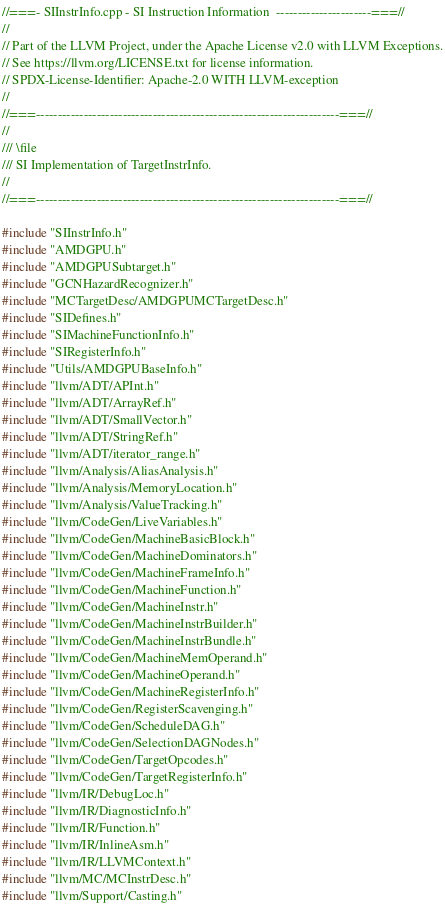<code> <loc_0><loc_0><loc_500><loc_500><_C++_>//===- SIInstrInfo.cpp - SI Instruction Information  ----------------------===//
//
// Part of the LLVM Project, under the Apache License v2.0 with LLVM Exceptions.
// See https://llvm.org/LICENSE.txt for license information.
// SPDX-License-Identifier: Apache-2.0 WITH LLVM-exception
//
//===----------------------------------------------------------------------===//
//
/// \file
/// SI Implementation of TargetInstrInfo.
//
//===----------------------------------------------------------------------===//

#include "SIInstrInfo.h"
#include "AMDGPU.h"
#include "AMDGPUSubtarget.h"
#include "GCNHazardRecognizer.h"
#include "MCTargetDesc/AMDGPUMCTargetDesc.h"
#include "SIDefines.h"
#include "SIMachineFunctionInfo.h"
#include "SIRegisterInfo.h"
#include "Utils/AMDGPUBaseInfo.h"
#include "llvm/ADT/APInt.h"
#include "llvm/ADT/ArrayRef.h"
#include "llvm/ADT/SmallVector.h"
#include "llvm/ADT/StringRef.h"
#include "llvm/ADT/iterator_range.h"
#include "llvm/Analysis/AliasAnalysis.h"
#include "llvm/Analysis/MemoryLocation.h"
#include "llvm/Analysis/ValueTracking.h"
#include "llvm/CodeGen/LiveVariables.h"
#include "llvm/CodeGen/MachineBasicBlock.h"
#include "llvm/CodeGen/MachineDominators.h"
#include "llvm/CodeGen/MachineFrameInfo.h"
#include "llvm/CodeGen/MachineFunction.h"
#include "llvm/CodeGen/MachineInstr.h"
#include "llvm/CodeGen/MachineInstrBuilder.h"
#include "llvm/CodeGen/MachineInstrBundle.h"
#include "llvm/CodeGen/MachineMemOperand.h"
#include "llvm/CodeGen/MachineOperand.h"
#include "llvm/CodeGen/MachineRegisterInfo.h"
#include "llvm/CodeGen/RegisterScavenging.h"
#include "llvm/CodeGen/ScheduleDAG.h"
#include "llvm/CodeGen/SelectionDAGNodes.h"
#include "llvm/CodeGen/TargetOpcodes.h"
#include "llvm/CodeGen/TargetRegisterInfo.h"
#include "llvm/IR/DebugLoc.h"
#include "llvm/IR/DiagnosticInfo.h"
#include "llvm/IR/Function.h"
#include "llvm/IR/InlineAsm.h"
#include "llvm/IR/LLVMContext.h"
#include "llvm/MC/MCInstrDesc.h"
#include "llvm/Support/Casting.h"</code> 